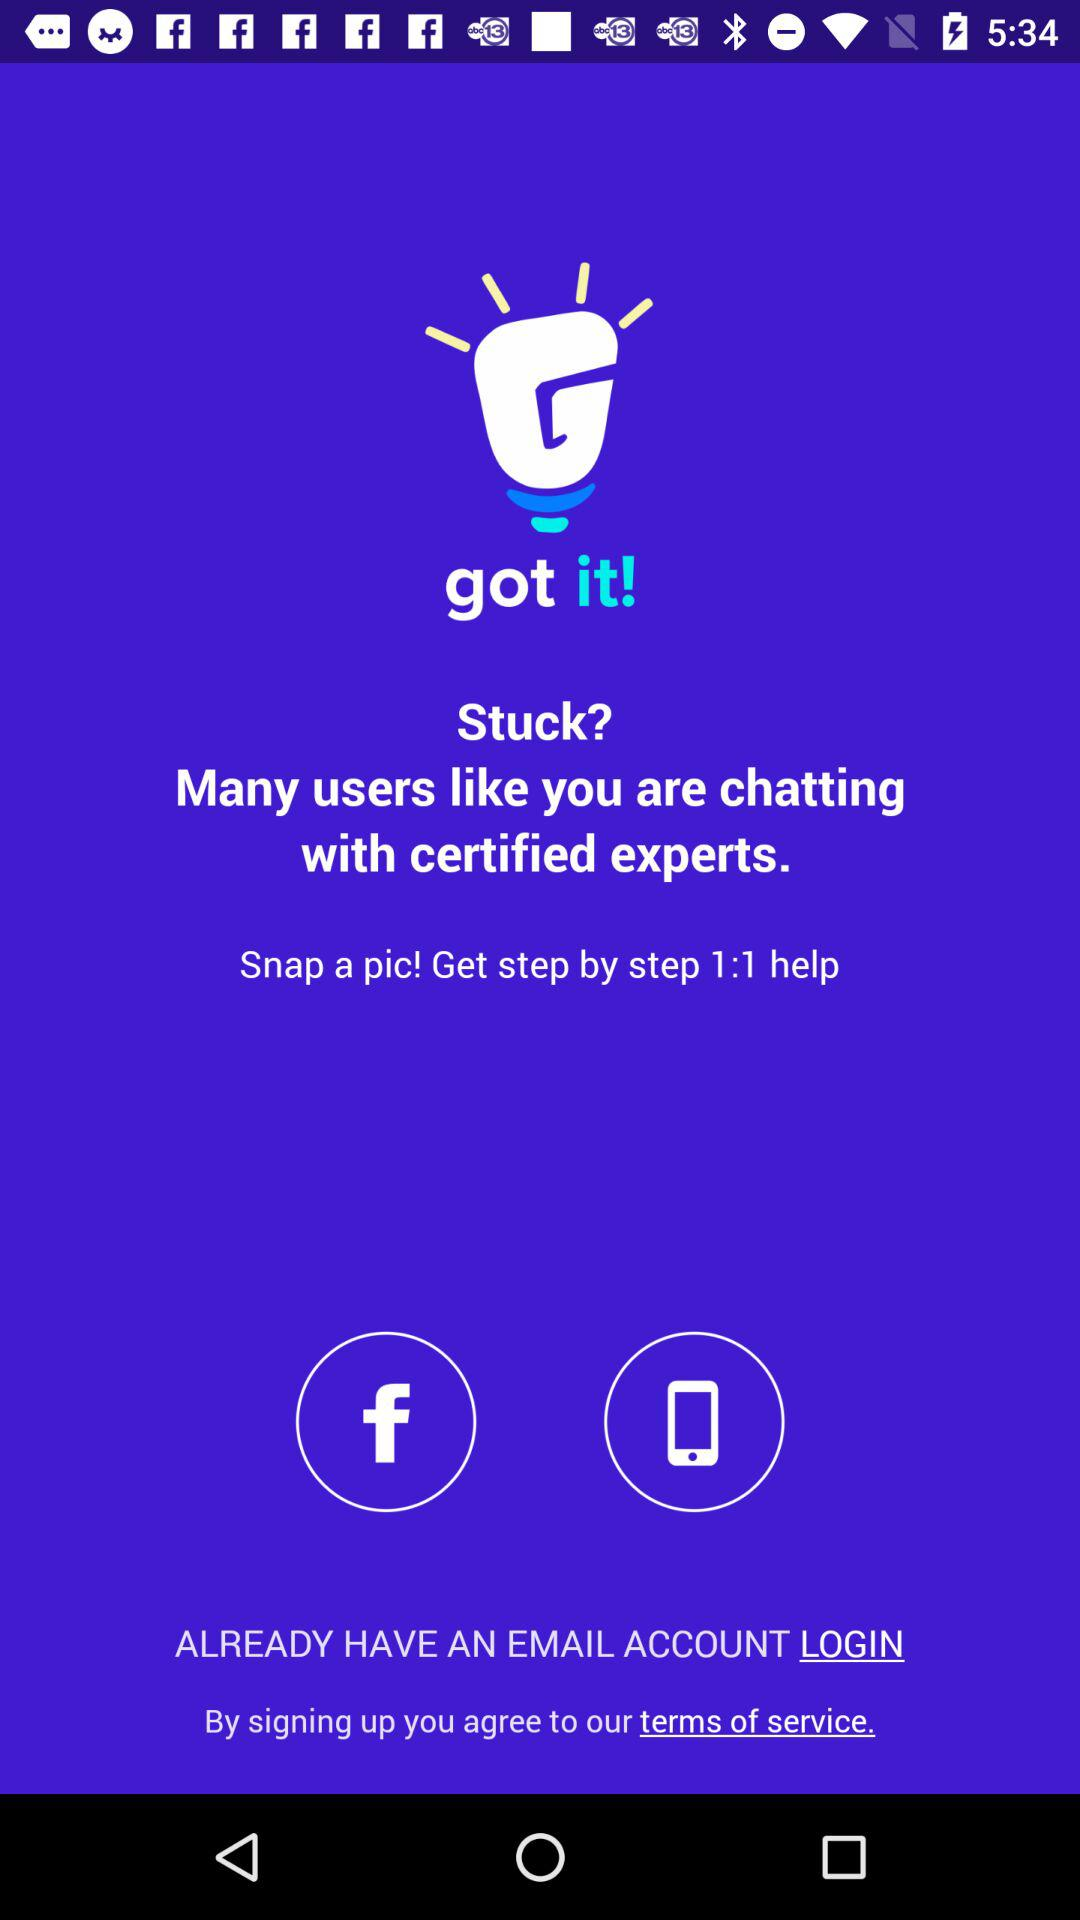Which option is there for logging in? The options for logging in are "Facebook", "Mobile" and "EMAIL". 